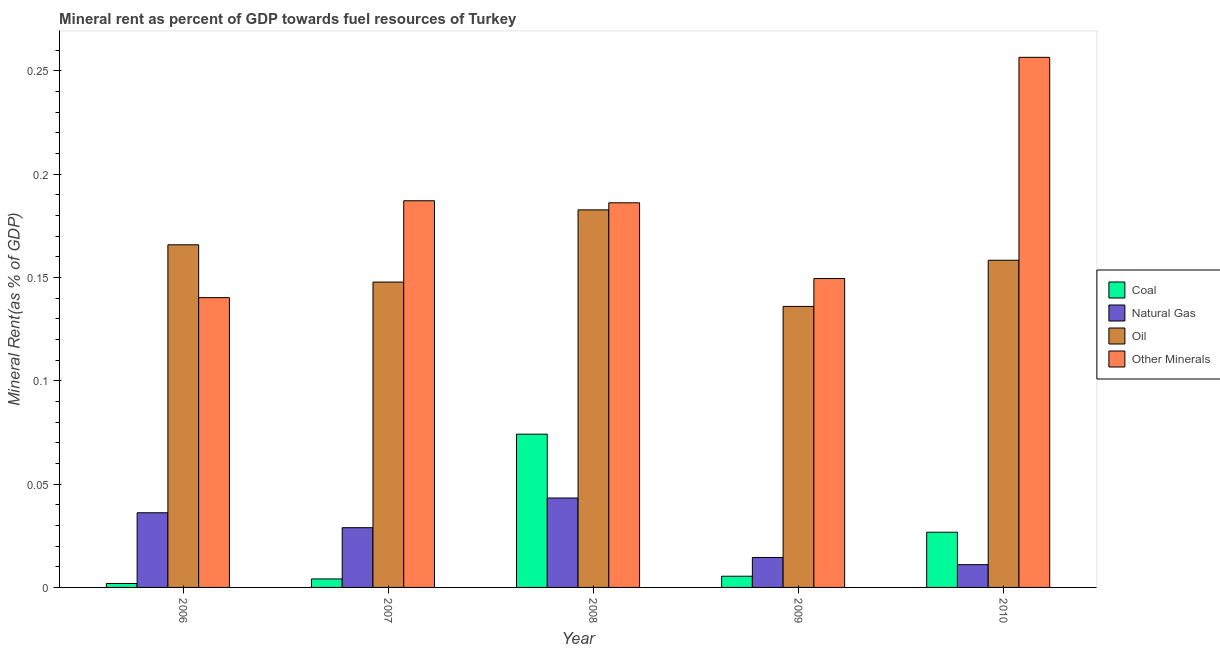How many different coloured bars are there?
Make the answer very short. 4. How many groups of bars are there?
Keep it short and to the point. 5. Are the number of bars per tick equal to the number of legend labels?
Ensure brevity in your answer.  Yes. What is the label of the 4th group of bars from the left?
Your answer should be compact. 2009. In how many cases, is the number of bars for a given year not equal to the number of legend labels?
Ensure brevity in your answer.  0. What is the natural gas rent in 2010?
Provide a short and direct response. 0.01. Across all years, what is the maximum coal rent?
Offer a very short reply. 0.07. Across all years, what is the minimum  rent of other minerals?
Offer a very short reply. 0.14. In which year was the  rent of other minerals maximum?
Give a very brief answer. 2010. In which year was the  rent of other minerals minimum?
Provide a short and direct response. 2006. What is the total natural gas rent in the graph?
Your response must be concise. 0.13. What is the difference between the natural gas rent in 2009 and that in 2010?
Your response must be concise. 0. What is the difference between the  rent of other minerals in 2007 and the oil rent in 2006?
Provide a succinct answer. 0.05. What is the average oil rent per year?
Offer a very short reply. 0.16. In how many years, is the  rent of other minerals greater than 0.08 %?
Offer a very short reply. 5. What is the ratio of the natural gas rent in 2008 to that in 2010?
Your response must be concise. 3.93. Is the  rent of other minerals in 2006 less than that in 2008?
Your answer should be compact. Yes. Is the difference between the natural gas rent in 2007 and 2010 greater than the difference between the oil rent in 2007 and 2010?
Ensure brevity in your answer.  No. What is the difference between the highest and the second highest  rent of other minerals?
Give a very brief answer. 0.07. What is the difference between the highest and the lowest  rent of other minerals?
Offer a very short reply. 0.12. Is the sum of the natural gas rent in 2006 and 2009 greater than the maximum  rent of other minerals across all years?
Provide a short and direct response. Yes. Is it the case that in every year, the sum of the coal rent and natural gas rent is greater than the sum of oil rent and  rent of other minerals?
Ensure brevity in your answer.  No. What does the 4th bar from the left in 2009 represents?
Your answer should be very brief. Other Minerals. What does the 1st bar from the right in 2008 represents?
Ensure brevity in your answer.  Other Minerals. Is it the case that in every year, the sum of the coal rent and natural gas rent is greater than the oil rent?
Your answer should be compact. No. How many bars are there?
Make the answer very short. 20. How many years are there in the graph?
Make the answer very short. 5. Are the values on the major ticks of Y-axis written in scientific E-notation?
Provide a short and direct response. No. Does the graph contain grids?
Make the answer very short. No. Where does the legend appear in the graph?
Keep it short and to the point. Center right. How are the legend labels stacked?
Keep it short and to the point. Vertical. What is the title of the graph?
Your answer should be very brief. Mineral rent as percent of GDP towards fuel resources of Turkey. Does "Other expenses" appear as one of the legend labels in the graph?
Give a very brief answer. No. What is the label or title of the X-axis?
Offer a very short reply. Year. What is the label or title of the Y-axis?
Provide a short and direct response. Mineral Rent(as % of GDP). What is the Mineral Rent(as % of GDP) of Coal in 2006?
Offer a very short reply. 0. What is the Mineral Rent(as % of GDP) of Natural Gas in 2006?
Your answer should be compact. 0.04. What is the Mineral Rent(as % of GDP) of Oil in 2006?
Offer a terse response. 0.17. What is the Mineral Rent(as % of GDP) in Other Minerals in 2006?
Keep it short and to the point. 0.14. What is the Mineral Rent(as % of GDP) in Coal in 2007?
Provide a succinct answer. 0. What is the Mineral Rent(as % of GDP) in Natural Gas in 2007?
Offer a very short reply. 0.03. What is the Mineral Rent(as % of GDP) in Oil in 2007?
Your response must be concise. 0.15. What is the Mineral Rent(as % of GDP) of Other Minerals in 2007?
Your response must be concise. 0.19. What is the Mineral Rent(as % of GDP) of Coal in 2008?
Your answer should be compact. 0.07. What is the Mineral Rent(as % of GDP) in Natural Gas in 2008?
Your response must be concise. 0.04. What is the Mineral Rent(as % of GDP) in Oil in 2008?
Ensure brevity in your answer.  0.18. What is the Mineral Rent(as % of GDP) in Other Minerals in 2008?
Offer a very short reply. 0.19. What is the Mineral Rent(as % of GDP) in Coal in 2009?
Provide a succinct answer. 0.01. What is the Mineral Rent(as % of GDP) in Natural Gas in 2009?
Make the answer very short. 0.01. What is the Mineral Rent(as % of GDP) of Oil in 2009?
Give a very brief answer. 0.14. What is the Mineral Rent(as % of GDP) in Other Minerals in 2009?
Your answer should be very brief. 0.15. What is the Mineral Rent(as % of GDP) of Coal in 2010?
Provide a succinct answer. 0.03. What is the Mineral Rent(as % of GDP) of Natural Gas in 2010?
Your answer should be very brief. 0.01. What is the Mineral Rent(as % of GDP) of Oil in 2010?
Keep it short and to the point. 0.16. What is the Mineral Rent(as % of GDP) in Other Minerals in 2010?
Your response must be concise. 0.26. Across all years, what is the maximum Mineral Rent(as % of GDP) in Coal?
Provide a succinct answer. 0.07. Across all years, what is the maximum Mineral Rent(as % of GDP) in Natural Gas?
Your answer should be compact. 0.04. Across all years, what is the maximum Mineral Rent(as % of GDP) in Oil?
Give a very brief answer. 0.18. Across all years, what is the maximum Mineral Rent(as % of GDP) of Other Minerals?
Offer a very short reply. 0.26. Across all years, what is the minimum Mineral Rent(as % of GDP) in Coal?
Ensure brevity in your answer.  0. Across all years, what is the minimum Mineral Rent(as % of GDP) of Natural Gas?
Your answer should be very brief. 0.01. Across all years, what is the minimum Mineral Rent(as % of GDP) in Oil?
Make the answer very short. 0.14. Across all years, what is the minimum Mineral Rent(as % of GDP) in Other Minerals?
Make the answer very short. 0.14. What is the total Mineral Rent(as % of GDP) in Coal in the graph?
Give a very brief answer. 0.11. What is the total Mineral Rent(as % of GDP) of Natural Gas in the graph?
Provide a succinct answer. 0.13. What is the total Mineral Rent(as % of GDP) of Oil in the graph?
Your answer should be compact. 0.79. What is the total Mineral Rent(as % of GDP) in Other Minerals in the graph?
Ensure brevity in your answer.  0.92. What is the difference between the Mineral Rent(as % of GDP) in Coal in 2006 and that in 2007?
Your answer should be compact. -0. What is the difference between the Mineral Rent(as % of GDP) in Natural Gas in 2006 and that in 2007?
Offer a very short reply. 0.01. What is the difference between the Mineral Rent(as % of GDP) in Oil in 2006 and that in 2007?
Your answer should be compact. 0.02. What is the difference between the Mineral Rent(as % of GDP) of Other Minerals in 2006 and that in 2007?
Provide a short and direct response. -0.05. What is the difference between the Mineral Rent(as % of GDP) in Coal in 2006 and that in 2008?
Provide a succinct answer. -0.07. What is the difference between the Mineral Rent(as % of GDP) in Natural Gas in 2006 and that in 2008?
Keep it short and to the point. -0.01. What is the difference between the Mineral Rent(as % of GDP) of Oil in 2006 and that in 2008?
Ensure brevity in your answer.  -0.02. What is the difference between the Mineral Rent(as % of GDP) of Other Minerals in 2006 and that in 2008?
Make the answer very short. -0.05. What is the difference between the Mineral Rent(as % of GDP) in Coal in 2006 and that in 2009?
Give a very brief answer. -0. What is the difference between the Mineral Rent(as % of GDP) in Natural Gas in 2006 and that in 2009?
Offer a terse response. 0.02. What is the difference between the Mineral Rent(as % of GDP) in Oil in 2006 and that in 2009?
Offer a very short reply. 0.03. What is the difference between the Mineral Rent(as % of GDP) of Other Minerals in 2006 and that in 2009?
Ensure brevity in your answer.  -0.01. What is the difference between the Mineral Rent(as % of GDP) of Coal in 2006 and that in 2010?
Offer a very short reply. -0.02. What is the difference between the Mineral Rent(as % of GDP) of Natural Gas in 2006 and that in 2010?
Your response must be concise. 0.03. What is the difference between the Mineral Rent(as % of GDP) in Oil in 2006 and that in 2010?
Your answer should be compact. 0.01. What is the difference between the Mineral Rent(as % of GDP) of Other Minerals in 2006 and that in 2010?
Your answer should be very brief. -0.12. What is the difference between the Mineral Rent(as % of GDP) of Coal in 2007 and that in 2008?
Make the answer very short. -0.07. What is the difference between the Mineral Rent(as % of GDP) in Natural Gas in 2007 and that in 2008?
Your answer should be very brief. -0.01. What is the difference between the Mineral Rent(as % of GDP) of Oil in 2007 and that in 2008?
Your answer should be very brief. -0.03. What is the difference between the Mineral Rent(as % of GDP) in Other Minerals in 2007 and that in 2008?
Ensure brevity in your answer.  0. What is the difference between the Mineral Rent(as % of GDP) in Coal in 2007 and that in 2009?
Make the answer very short. -0. What is the difference between the Mineral Rent(as % of GDP) in Natural Gas in 2007 and that in 2009?
Provide a short and direct response. 0.01. What is the difference between the Mineral Rent(as % of GDP) in Oil in 2007 and that in 2009?
Keep it short and to the point. 0.01. What is the difference between the Mineral Rent(as % of GDP) in Other Minerals in 2007 and that in 2009?
Keep it short and to the point. 0.04. What is the difference between the Mineral Rent(as % of GDP) of Coal in 2007 and that in 2010?
Keep it short and to the point. -0.02. What is the difference between the Mineral Rent(as % of GDP) in Natural Gas in 2007 and that in 2010?
Provide a short and direct response. 0.02. What is the difference between the Mineral Rent(as % of GDP) of Oil in 2007 and that in 2010?
Offer a very short reply. -0.01. What is the difference between the Mineral Rent(as % of GDP) in Other Minerals in 2007 and that in 2010?
Make the answer very short. -0.07. What is the difference between the Mineral Rent(as % of GDP) of Coal in 2008 and that in 2009?
Offer a terse response. 0.07. What is the difference between the Mineral Rent(as % of GDP) of Natural Gas in 2008 and that in 2009?
Your answer should be very brief. 0.03. What is the difference between the Mineral Rent(as % of GDP) of Oil in 2008 and that in 2009?
Give a very brief answer. 0.05. What is the difference between the Mineral Rent(as % of GDP) of Other Minerals in 2008 and that in 2009?
Make the answer very short. 0.04. What is the difference between the Mineral Rent(as % of GDP) of Coal in 2008 and that in 2010?
Your response must be concise. 0.05. What is the difference between the Mineral Rent(as % of GDP) of Natural Gas in 2008 and that in 2010?
Your response must be concise. 0.03. What is the difference between the Mineral Rent(as % of GDP) of Oil in 2008 and that in 2010?
Your answer should be very brief. 0.02. What is the difference between the Mineral Rent(as % of GDP) in Other Minerals in 2008 and that in 2010?
Offer a terse response. -0.07. What is the difference between the Mineral Rent(as % of GDP) of Coal in 2009 and that in 2010?
Offer a very short reply. -0.02. What is the difference between the Mineral Rent(as % of GDP) of Natural Gas in 2009 and that in 2010?
Provide a short and direct response. 0. What is the difference between the Mineral Rent(as % of GDP) of Oil in 2009 and that in 2010?
Your answer should be compact. -0.02. What is the difference between the Mineral Rent(as % of GDP) in Other Minerals in 2009 and that in 2010?
Your response must be concise. -0.11. What is the difference between the Mineral Rent(as % of GDP) in Coal in 2006 and the Mineral Rent(as % of GDP) in Natural Gas in 2007?
Offer a very short reply. -0.03. What is the difference between the Mineral Rent(as % of GDP) in Coal in 2006 and the Mineral Rent(as % of GDP) in Oil in 2007?
Provide a succinct answer. -0.15. What is the difference between the Mineral Rent(as % of GDP) of Coal in 2006 and the Mineral Rent(as % of GDP) of Other Minerals in 2007?
Make the answer very short. -0.19. What is the difference between the Mineral Rent(as % of GDP) in Natural Gas in 2006 and the Mineral Rent(as % of GDP) in Oil in 2007?
Offer a very short reply. -0.11. What is the difference between the Mineral Rent(as % of GDP) of Natural Gas in 2006 and the Mineral Rent(as % of GDP) of Other Minerals in 2007?
Keep it short and to the point. -0.15. What is the difference between the Mineral Rent(as % of GDP) in Oil in 2006 and the Mineral Rent(as % of GDP) in Other Minerals in 2007?
Offer a terse response. -0.02. What is the difference between the Mineral Rent(as % of GDP) in Coal in 2006 and the Mineral Rent(as % of GDP) in Natural Gas in 2008?
Offer a terse response. -0.04. What is the difference between the Mineral Rent(as % of GDP) in Coal in 2006 and the Mineral Rent(as % of GDP) in Oil in 2008?
Offer a very short reply. -0.18. What is the difference between the Mineral Rent(as % of GDP) in Coal in 2006 and the Mineral Rent(as % of GDP) in Other Minerals in 2008?
Your response must be concise. -0.18. What is the difference between the Mineral Rent(as % of GDP) in Natural Gas in 2006 and the Mineral Rent(as % of GDP) in Oil in 2008?
Ensure brevity in your answer.  -0.15. What is the difference between the Mineral Rent(as % of GDP) of Oil in 2006 and the Mineral Rent(as % of GDP) of Other Minerals in 2008?
Your answer should be compact. -0.02. What is the difference between the Mineral Rent(as % of GDP) of Coal in 2006 and the Mineral Rent(as % of GDP) of Natural Gas in 2009?
Provide a succinct answer. -0.01. What is the difference between the Mineral Rent(as % of GDP) of Coal in 2006 and the Mineral Rent(as % of GDP) of Oil in 2009?
Your answer should be compact. -0.13. What is the difference between the Mineral Rent(as % of GDP) in Coal in 2006 and the Mineral Rent(as % of GDP) in Other Minerals in 2009?
Your answer should be compact. -0.15. What is the difference between the Mineral Rent(as % of GDP) in Natural Gas in 2006 and the Mineral Rent(as % of GDP) in Oil in 2009?
Your answer should be compact. -0.1. What is the difference between the Mineral Rent(as % of GDP) of Natural Gas in 2006 and the Mineral Rent(as % of GDP) of Other Minerals in 2009?
Your answer should be very brief. -0.11. What is the difference between the Mineral Rent(as % of GDP) of Oil in 2006 and the Mineral Rent(as % of GDP) of Other Minerals in 2009?
Your answer should be compact. 0.02. What is the difference between the Mineral Rent(as % of GDP) in Coal in 2006 and the Mineral Rent(as % of GDP) in Natural Gas in 2010?
Your response must be concise. -0.01. What is the difference between the Mineral Rent(as % of GDP) of Coal in 2006 and the Mineral Rent(as % of GDP) of Oil in 2010?
Your answer should be compact. -0.16. What is the difference between the Mineral Rent(as % of GDP) in Coal in 2006 and the Mineral Rent(as % of GDP) in Other Minerals in 2010?
Make the answer very short. -0.25. What is the difference between the Mineral Rent(as % of GDP) in Natural Gas in 2006 and the Mineral Rent(as % of GDP) in Oil in 2010?
Your answer should be very brief. -0.12. What is the difference between the Mineral Rent(as % of GDP) of Natural Gas in 2006 and the Mineral Rent(as % of GDP) of Other Minerals in 2010?
Your answer should be compact. -0.22. What is the difference between the Mineral Rent(as % of GDP) of Oil in 2006 and the Mineral Rent(as % of GDP) of Other Minerals in 2010?
Offer a very short reply. -0.09. What is the difference between the Mineral Rent(as % of GDP) of Coal in 2007 and the Mineral Rent(as % of GDP) of Natural Gas in 2008?
Keep it short and to the point. -0.04. What is the difference between the Mineral Rent(as % of GDP) of Coal in 2007 and the Mineral Rent(as % of GDP) of Oil in 2008?
Provide a succinct answer. -0.18. What is the difference between the Mineral Rent(as % of GDP) in Coal in 2007 and the Mineral Rent(as % of GDP) in Other Minerals in 2008?
Your answer should be compact. -0.18. What is the difference between the Mineral Rent(as % of GDP) in Natural Gas in 2007 and the Mineral Rent(as % of GDP) in Oil in 2008?
Keep it short and to the point. -0.15. What is the difference between the Mineral Rent(as % of GDP) in Natural Gas in 2007 and the Mineral Rent(as % of GDP) in Other Minerals in 2008?
Ensure brevity in your answer.  -0.16. What is the difference between the Mineral Rent(as % of GDP) of Oil in 2007 and the Mineral Rent(as % of GDP) of Other Minerals in 2008?
Offer a terse response. -0.04. What is the difference between the Mineral Rent(as % of GDP) in Coal in 2007 and the Mineral Rent(as % of GDP) in Natural Gas in 2009?
Your answer should be very brief. -0.01. What is the difference between the Mineral Rent(as % of GDP) in Coal in 2007 and the Mineral Rent(as % of GDP) in Oil in 2009?
Your answer should be very brief. -0.13. What is the difference between the Mineral Rent(as % of GDP) in Coal in 2007 and the Mineral Rent(as % of GDP) in Other Minerals in 2009?
Ensure brevity in your answer.  -0.15. What is the difference between the Mineral Rent(as % of GDP) in Natural Gas in 2007 and the Mineral Rent(as % of GDP) in Oil in 2009?
Your response must be concise. -0.11. What is the difference between the Mineral Rent(as % of GDP) of Natural Gas in 2007 and the Mineral Rent(as % of GDP) of Other Minerals in 2009?
Provide a short and direct response. -0.12. What is the difference between the Mineral Rent(as % of GDP) of Oil in 2007 and the Mineral Rent(as % of GDP) of Other Minerals in 2009?
Ensure brevity in your answer.  -0. What is the difference between the Mineral Rent(as % of GDP) of Coal in 2007 and the Mineral Rent(as % of GDP) of Natural Gas in 2010?
Keep it short and to the point. -0.01. What is the difference between the Mineral Rent(as % of GDP) in Coal in 2007 and the Mineral Rent(as % of GDP) in Oil in 2010?
Your response must be concise. -0.15. What is the difference between the Mineral Rent(as % of GDP) in Coal in 2007 and the Mineral Rent(as % of GDP) in Other Minerals in 2010?
Your response must be concise. -0.25. What is the difference between the Mineral Rent(as % of GDP) in Natural Gas in 2007 and the Mineral Rent(as % of GDP) in Oil in 2010?
Keep it short and to the point. -0.13. What is the difference between the Mineral Rent(as % of GDP) in Natural Gas in 2007 and the Mineral Rent(as % of GDP) in Other Minerals in 2010?
Provide a short and direct response. -0.23. What is the difference between the Mineral Rent(as % of GDP) in Oil in 2007 and the Mineral Rent(as % of GDP) in Other Minerals in 2010?
Provide a succinct answer. -0.11. What is the difference between the Mineral Rent(as % of GDP) in Coal in 2008 and the Mineral Rent(as % of GDP) in Natural Gas in 2009?
Provide a succinct answer. 0.06. What is the difference between the Mineral Rent(as % of GDP) of Coal in 2008 and the Mineral Rent(as % of GDP) of Oil in 2009?
Your answer should be very brief. -0.06. What is the difference between the Mineral Rent(as % of GDP) of Coal in 2008 and the Mineral Rent(as % of GDP) of Other Minerals in 2009?
Your answer should be very brief. -0.08. What is the difference between the Mineral Rent(as % of GDP) of Natural Gas in 2008 and the Mineral Rent(as % of GDP) of Oil in 2009?
Make the answer very short. -0.09. What is the difference between the Mineral Rent(as % of GDP) of Natural Gas in 2008 and the Mineral Rent(as % of GDP) of Other Minerals in 2009?
Your answer should be very brief. -0.11. What is the difference between the Mineral Rent(as % of GDP) in Oil in 2008 and the Mineral Rent(as % of GDP) in Other Minerals in 2009?
Provide a succinct answer. 0.03. What is the difference between the Mineral Rent(as % of GDP) of Coal in 2008 and the Mineral Rent(as % of GDP) of Natural Gas in 2010?
Your answer should be very brief. 0.06. What is the difference between the Mineral Rent(as % of GDP) of Coal in 2008 and the Mineral Rent(as % of GDP) of Oil in 2010?
Your answer should be compact. -0.08. What is the difference between the Mineral Rent(as % of GDP) of Coal in 2008 and the Mineral Rent(as % of GDP) of Other Minerals in 2010?
Ensure brevity in your answer.  -0.18. What is the difference between the Mineral Rent(as % of GDP) of Natural Gas in 2008 and the Mineral Rent(as % of GDP) of Oil in 2010?
Your answer should be compact. -0.12. What is the difference between the Mineral Rent(as % of GDP) in Natural Gas in 2008 and the Mineral Rent(as % of GDP) in Other Minerals in 2010?
Ensure brevity in your answer.  -0.21. What is the difference between the Mineral Rent(as % of GDP) of Oil in 2008 and the Mineral Rent(as % of GDP) of Other Minerals in 2010?
Make the answer very short. -0.07. What is the difference between the Mineral Rent(as % of GDP) in Coal in 2009 and the Mineral Rent(as % of GDP) in Natural Gas in 2010?
Provide a succinct answer. -0.01. What is the difference between the Mineral Rent(as % of GDP) of Coal in 2009 and the Mineral Rent(as % of GDP) of Oil in 2010?
Offer a terse response. -0.15. What is the difference between the Mineral Rent(as % of GDP) in Coal in 2009 and the Mineral Rent(as % of GDP) in Other Minerals in 2010?
Provide a short and direct response. -0.25. What is the difference between the Mineral Rent(as % of GDP) of Natural Gas in 2009 and the Mineral Rent(as % of GDP) of Oil in 2010?
Give a very brief answer. -0.14. What is the difference between the Mineral Rent(as % of GDP) in Natural Gas in 2009 and the Mineral Rent(as % of GDP) in Other Minerals in 2010?
Ensure brevity in your answer.  -0.24. What is the difference between the Mineral Rent(as % of GDP) in Oil in 2009 and the Mineral Rent(as % of GDP) in Other Minerals in 2010?
Offer a terse response. -0.12. What is the average Mineral Rent(as % of GDP) of Coal per year?
Provide a short and direct response. 0.02. What is the average Mineral Rent(as % of GDP) of Natural Gas per year?
Your answer should be compact. 0.03. What is the average Mineral Rent(as % of GDP) in Oil per year?
Keep it short and to the point. 0.16. What is the average Mineral Rent(as % of GDP) in Other Minerals per year?
Offer a terse response. 0.18. In the year 2006, what is the difference between the Mineral Rent(as % of GDP) of Coal and Mineral Rent(as % of GDP) of Natural Gas?
Offer a terse response. -0.03. In the year 2006, what is the difference between the Mineral Rent(as % of GDP) of Coal and Mineral Rent(as % of GDP) of Oil?
Provide a short and direct response. -0.16. In the year 2006, what is the difference between the Mineral Rent(as % of GDP) in Coal and Mineral Rent(as % of GDP) in Other Minerals?
Offer a very short reply. -0.14. In the year 2006, what is the difference between the Mineral Rent(as % of GDP) of Natural Gas and Mineral Rent(as % of GDP) of Oil?
Your response must be concise. -0.13. In the year 2006, what is the difference between the Mineral Rent(as % of GDP) of Natural Gas and Mineral Rent(as % of GDP) of Other Minerals?
Give a very brief answer. -0.1. In the year 2006, what is the difference between the Mineral Rent(as % of GDP) of Oil and Mineral Rent(as % of GDP) of Other Minerals?
Make the answer very short. 0.03. In the year 2007, what is the difference between the Mineral Rent(as % of GDP) of Coal and Mineral Rent(as % of GDP) of Natural Gas?
Your answer should be compact. -0.02. In the year 2007, what is the difference between the Mineral Rent(as % of GDP) in Coal and Mineral Rent(as % of GDP) in Oil?
Provide a succinct answer. -0.14. In the year 2007, what is the difference between the Mineral Rent(as % of GDP) in Coal and Mineral Rent(as % of GDP) in Other Minerals?
Your answer should be very brief. -0.18. In the year 2007, what is the difference between the Mineral Rent(as % of GDP) in Natural Gas and Mineral Rent(as % of GDP) in Oil?
Your response must be concise. -0.12. In the year 2007, what is the difference between the Mineral Rent(as % of GDP) of Natural Gas and Mineral Rent(as % of GDP) of Other Minerals?
Provide a succinct answer. -0.16. In the year 2007, what is the difference between the Mineral Rent(as % of GDP) in Oil and Mineral Rent(as % of GDP) in Other Minerals?
Give a very brief answer. -0.04. In the year 2008, what is the difference between the Mineral Rent(as % of GDP) in Coal and Mineral Rent(as % of GDP) in Natural Gas?
Your answer should be very brief. 0.03. In the year 2008, what is the difference between the Mineral Rent(as % of GDP) in Coal and Mineral Rent(as % of GDP) in Oil?
Your answer should be compact. -0.11. In the year 2008, what is the difference between the Mineral Rent(as % of GDP) in Coal and Mineral Rent(as % of GDP) in Other Minerals?
Keep it short and to the point. -0.11. In the year 2008, what is the difference between the Mineral Rent(as % of GDP) in Natural Gas and Mineral Rent(as % of GDP) in Oil?
Ensure brevity in your answer.  -0.14. In the year 2008, what is the difference between the Mineral Rent(as % of GDP) in Natural Gas and Mineral Rent(as % of GDP) in Other Minerals?
Ensure brevity in your answer.  -0.14. In the year 2008, what is the difference between the Mineral Rent(as % of GDP) of Oil and Mineral Rent(as % of GDP) of Other Minerals?
Provide a succinct answer. -0. In the year 2009, what is the difference between the Mineral Rent(as % of GDP) in Coal and Mineral Rent(as % of GDP) in Natural Gas?
Provide a succinct answer. -0.01. In the year 2009, what is the difference between the Mineral Rent(as % of GDP) of Coal and Mineral Rent(as % of GDP) of Oil?
Provide a succinct answer. -0.13. In the year 2009, what is the difference between the Mineral Rent(as % of GDP) in Coal and Mineral Rent(as % of GDP) in Other Minerals?
Provide a short and direct response. -0.14. In the year 2009, what is the difference between the Mineral Rent(as % of GDP) in Natural Gas and Mineral Rent(as % of GDP) in Oil?
Keep it short and to the point. -0.12. In the year 2009, what is the difference between the Mineral Rent(as % of GDP) of Natural Gas and Mineral Rent(as % of GDP) of Other Minerals?
Offer a terse response. -0.14. In the year 2009, what is the difference between the Mineral Rent(as % of GDP) in Oil and Mineral Rent(as % of GDP) in Other Minerals?
Make the answer very short. -0.01. In the year 2010, what is the difference between the Mineral Rent(as % of GDP) in Coal and Mineral Rent(as % of GDP) in Natural Gas?
Keep it short and to the point. 0.02. In the year 2010, what is the difference between the Mineral Rent(as % of GDP) of Coal and Mineral Rent(as % of GDP) of Oil?
Give a very brief answer. -0.13. In the year 2010, what is the difference between the Mineral Rent(as % of GDP) of Coal and Mineral Rent(as % of GDP) of Other Minerals?
Ensure brevity in your answer.  -0.23. In the year 2010, what is the difference between the Mineral Rent(as % of GDP) in Natural Gas and Mineral Rent(as % of GDP) in Oil?
Your answer should be compact. -0.15. In the year 2010, what is the difference between the Mineral Rent(as % of GDP) in Natural Gas and Mineral Rent(as % of GDP) in Other Minerals?
Offer a very short reply. -0.25. In the year 2010, what is the difference between the Mineral Rent(as % of GDP) in Oil and Mineral Rent(as % of GDP) in Other Minerals?
Provide a succinct answer. -0.1. What is the ratio of the Mineral Rent(as % of GDP) of Coal in 2006 to that in 2007?
Offer a terse response. 0.46. What is the ratio of the Mineral Rent(as % of GDP) in Natural Gas in 2006 to that in 2007?
Your response must be concise. 1.25. What is the ratio of the Mineral Rent(as % of GDP) of Oil in 2006 to that in 2007?
Provide a succinct answer. 1.12. What is the ratio of the Mineral Rent(as % of GDP) in Other Minerals in 2006 to that in 2007?
Keep it short and to the point. 0.75. What is the ratio of the Mineral Rent(as % of GDP) in Coal in 2006 to that in 2008?
Your answer should be very brief. 0.03. What is the ratio of the Mineral Rent(as % of GDP) in Natural Gas in 2006 to that in 2008?
Ensure brevity in your answer.  0.83. What is the ratio of the Mineral Rent(as % of GDP) in Oil in 2006 to that in 2008?
Your answer should be very brief. 0.91. What is the ratio of the Mineral Rent(as % of GDP) of Other Minerals in 2006 to that in 2008?
Give a very brief answer. 0.75. What is the ratio of the Mineral Rent(as % of GDP) in Coal in 2006 to that in 2009?
Your answer should be very brief. 0.35. What is the ratio of the Mineral Rent(as % of GDP) in Natural Gas in 2006 to that in 2009?
Make the answer very short. 2.49. What is the ratio of the Mineral Rent(as % of GDP) of Oil in 2006 to that in 2009?
Make the answer very short. 1.22. What is the ratio of the Mineral Rent(as % of GDP) of Other Minerals in 2006 to that in 2009?
Provide a succinct answer. 0.94. What is the ratio of the Mineral Rent(as % of GDP) in Coal in 2006 to that in 2010?
Make the answer very short. 0.07. What is the ratio of the Mineral Rent(as % of GDP) in Natural Gas in 2006 to that in 2010?
Offer a very short reply. 3.28. What is the ratio of the Mineral Rent(as % of GDP) of Oil in 2006 to that in 2010?
Offer a terse response. 1.05. What is the ratio of the Mineral Rent(as % of GDP) of Other Minerals in 2006 to that in 2010?
Make the answer very short. 0.55. What is the ratio of the Mineral Rent(as % of GDP) in Coal in 2007 to that in 2008?
Your response must be concise. 0.06. What is the ratio of the Mineral Rent(as % of GDP) in Natural Gas in 2007 to that in 2008?
Provide a short and direct response. 0.67. What is the ratio of the Mineral Rent(as % of GDP) in Oil in 2007 to that in 2008?
Your response must be concise. 0.81. What is the ratio of the Mineral Rent(as % of GDP) in Coal in 2007 to that in 2009?
Offer a terse response. 0.76. What is the ratio of the Mineral Rent(as % of GDP) in Natural Gas in 2007 to that in 2009?
Provide a succinct answer. 2. What is the ratio of the Mineral Rent(as % of GDP) of Oil in 2007 to that in 2009?
Make the answer very short. 1.09. What is the ratio of the Mineral Rent(as % of GDP) of Other Minerals in 2007 to that in 2009?
Your answer should be very brief. 1.25. What is the ratio of the Mineral Rent(as % of GDP) of Coal in 2007 to that in 2010?
Offer a very short reply. 0.15. What is the ratio of the Mineral Rent(as % of GDP) in Natural Gas in 2007 to that in 2010?
Your answer should be compact. 2.62. What is the ratio of the Mineral Rent(as % of GDP) in Oil in 2007 to that in 2010?
Your response must be concise. 0.93. What is the ratio of the Mineral Rent(as % of GDP) of Other Minerals in 2007 to that in 2010?
Your answer should be very brief. 0.73. What is the ratio of the Mineral Rent(as % of GDP) in Coal in 2008 to that in 2009?
Offer a terse response. 13.69. What is the ratio of the Mineral Rent(as % of GDP) in Natural Gas in 2008 to that in 2009?
Make the answer very short. 2.99. What is the ratio of the Mineral Rent(as % of GDP) of Oil in 2008 to that in 2009?
Offer a very short reply. 1.34. What is the ratio of the Mineral Rent(as % of GDP) in Other Minerals in 2008 to that in 2009?
Offer a terse response. 1.25. What is the ratio of the Mineral Rent(as % of GDP) of Coal in 2008 to that in 2010?
Offer a terse response. 2.78. What is the ratio of the Mineral Rent(as % of GDP) in Natural Gas in 2008 to that in 2010?
Offer a very short reply. 3.93. What is the ratio of the Mineral Rent(as % of GDP) in Oil in 2008 to that in 2010?
Offer a very short reply. 1.15. What is the ratio of the Mineral Rent(as % of GDP) in Other Minerals in 2008 to that in 2010?
Your answer should be compact. 0.73. What is the ratio of the Mineral Rent(as % of GDP) of Coal in 2009 to that in 2010?
Your answer should be very brief. 0.2. What is the ratio of the Mineral Rent(as % of GDP) in Natural Gas in 2009 to that in 2010?
Offer a very short reply. 1.31. What is the ratio of the Mineral Rent(as % of GDP) in Oil in 2009 to that in 2010?
Your answer should be compact. 0.86. What is the ratio of the Mineral Rent(as % of GDP) in Other Minerals in 2009 to that in 2010?
Keep it short and to the point. 0.58. What is the difference between the highest and the second highest Mineral Rent(as % of GDP) of Coal?
Give a very brief answer. 0.05. What is the difference between the highest and the second highest Mineral Rent(as % of GDP) of Natural Gas?
Your response must be concise. 0.01. What is the difference between the highest and the second highest Mineral Rent(as % of GDP) in Oil?
Ensure brevity in your answer.  0.02. What is the difference between the highest and the second highest Mineral Rent(as % of GDP) in Other Minerals?
Make the answer very short. 0.07. What is the difference between the highest and the lowest Mineral Rent(as % of GDP) of Coal?
Provide a succinct answer. 0.07. What is the difference between the highest and the lowest Mineral Rent(as % of GDP) of Natural Gas?
Keep it short and to the point. 0.03. What is the difference between the highest and the lowest Mineral Rent(as % of GDP) in Oil?
Ensure brevity in your answer.  0.05. What is the difference between the highest and the lowest Mineral Rent(as % of GDP) in Other Minerals?
Offer a terse response. 0.12. 